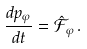Convert formula to latex. <formula><loc_0><loc_0><loc_500><loc_500>\frac { d p _ { \varphi } } { d t } = \hat { \mathcal { F } } _ { \varphi } \, .</formula> 